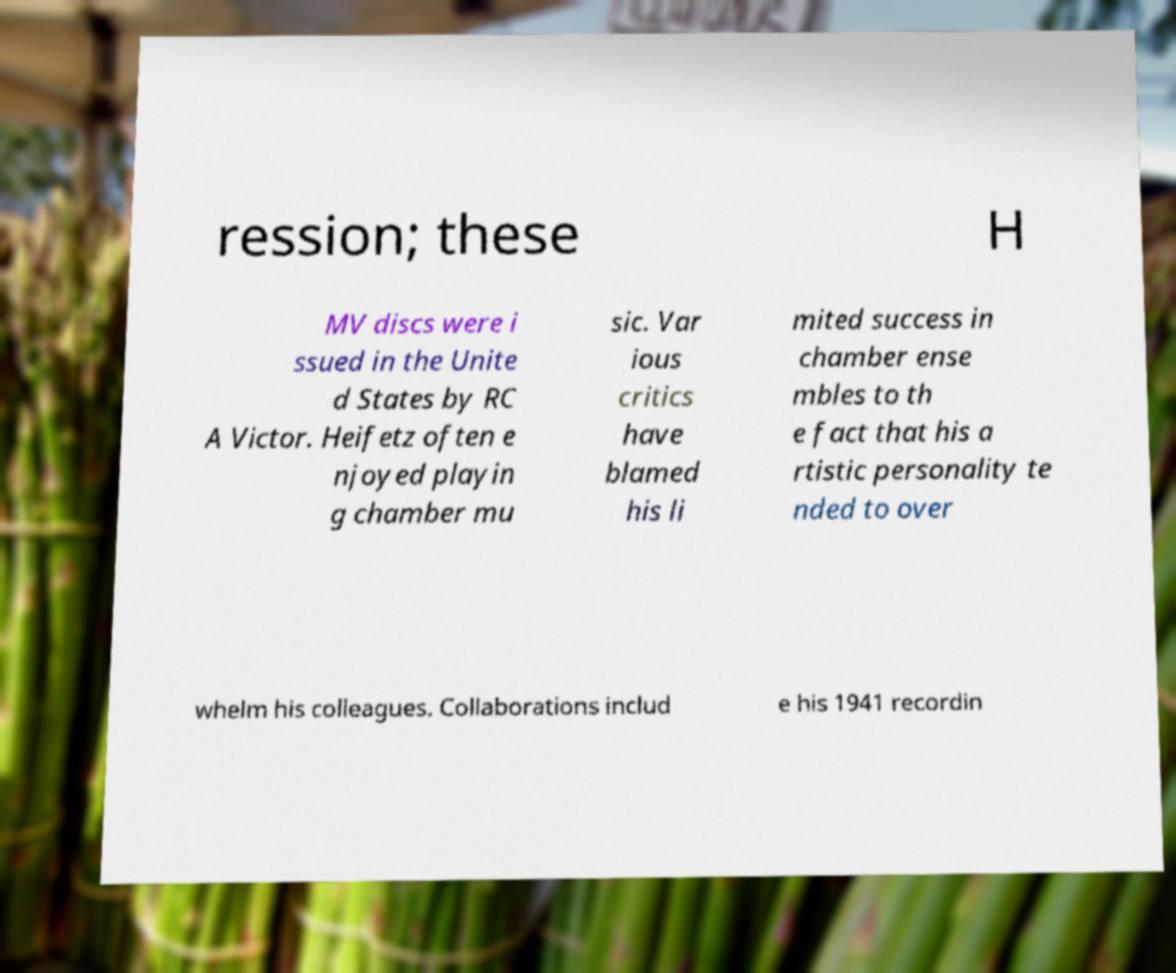I need the written content from this picture converted into text. Can you do that? ression; these H MV discs were i ssued in the Unite d States by RC A Victor. Heifetz often e njoyed playin g chamber mu sic. Var ious critics have blamed his li mited success in chamber ense mbles to th e fact that his a rtistic personality te nded to over whelm his colleagues. Collaborations includ e his 1941 recordin 